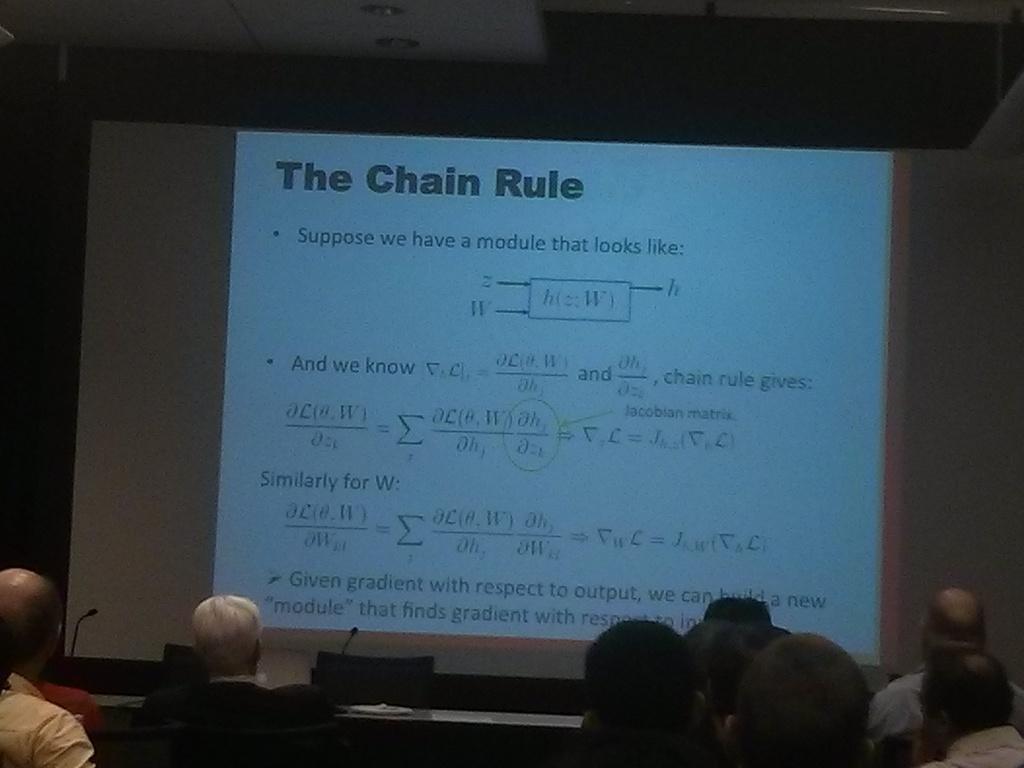Could you give a brief overview of what you see in this image? In this image we can see many people sitting. There are chairs. Also there are tables with mics. In the back there is a wall with a screen. On the screen something is written. 